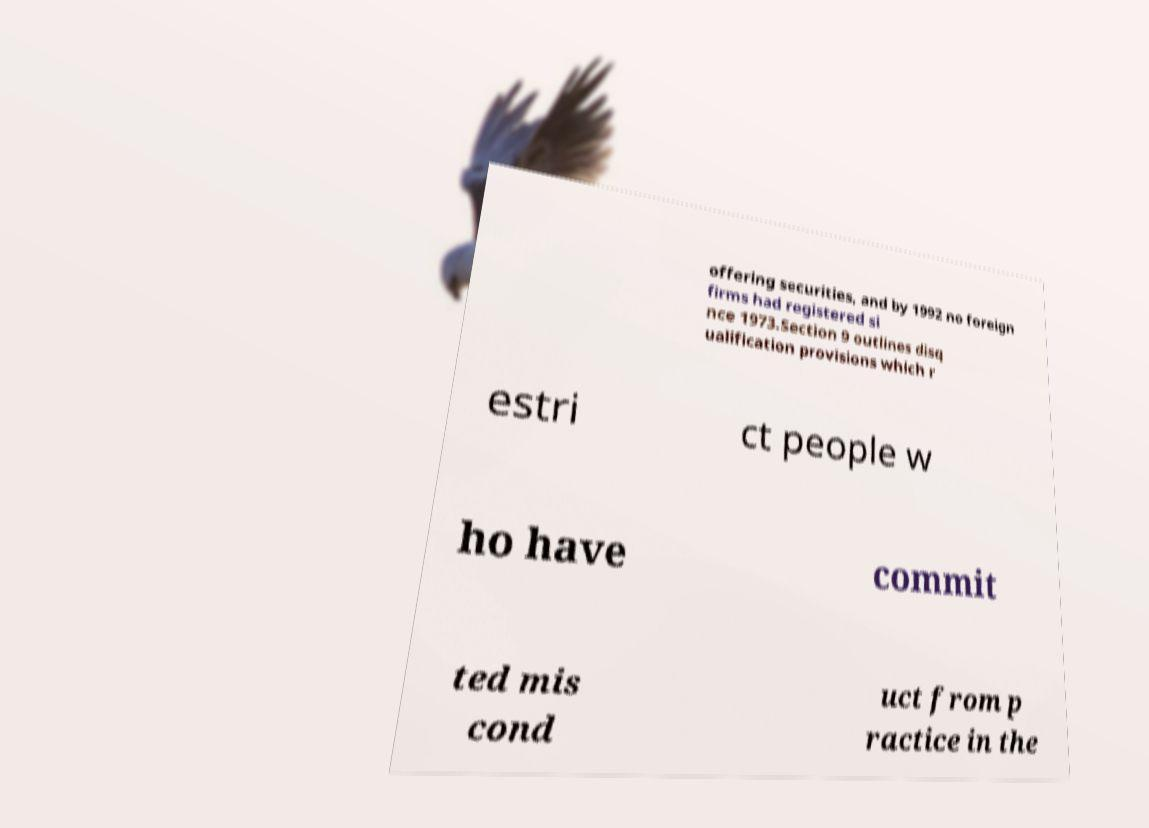I need the written content from this picture converted into text. Can you do that? offering securities, and by 1992 no foreign firms had registered si nce 1973.Section 9 outlines disq ualification provisions which r estri ct people w ho have commit ted mis cond uct from p ractice in the 